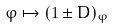<formula> <loc_0><loc_0><loc_500><loc_500>\varphi \mapsto ( 1 \pm D ) _ { \varphi }</formula> 